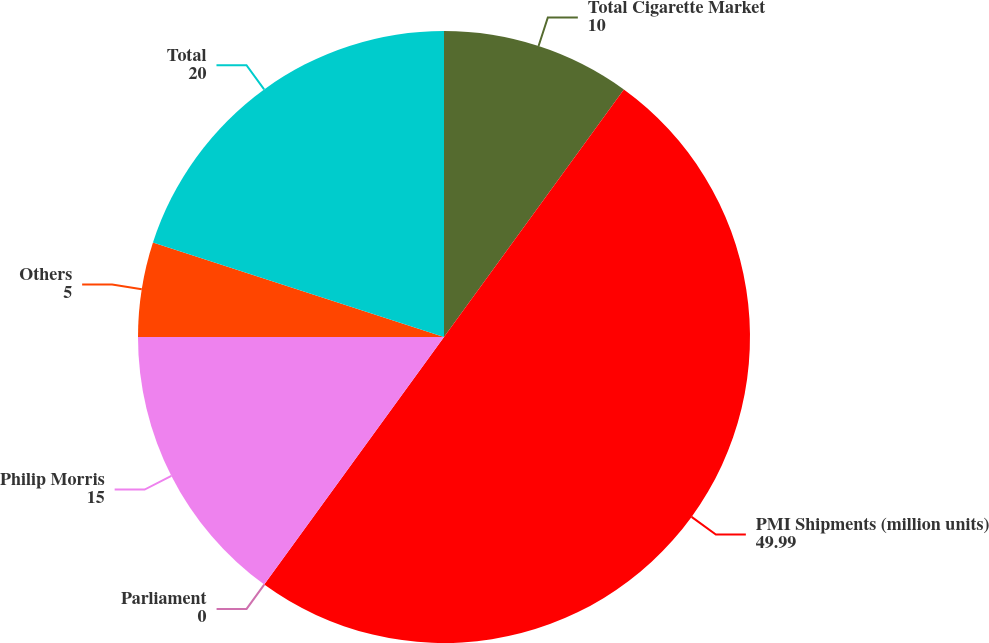Convert chart. <chart><loc_0><loc_0><loc_500><loc_500><pie_chart><fcel>Total Cigarette Market<fcel>PMI Shipments (million units)<fcel>Parliament<fcel>Philip Morris<fcel>Others<fcel>Total<nl><fcel>10.0%<fcel>49.99%<fcel>0.0%<fcel>15.0%<fcel>5.0%<fcel>20.0%<nl></chart> 